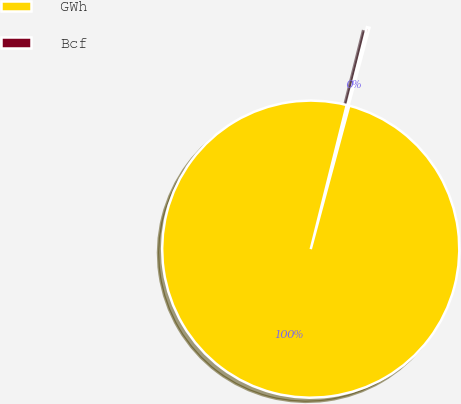Convert chart. <chart><loc_0><loc_0><loc_500><loc_500><pie_chart><fcel>GWh<fcel>Bcf<nl><fcel>99.72%<fcel>0.28%<nl></chart> 